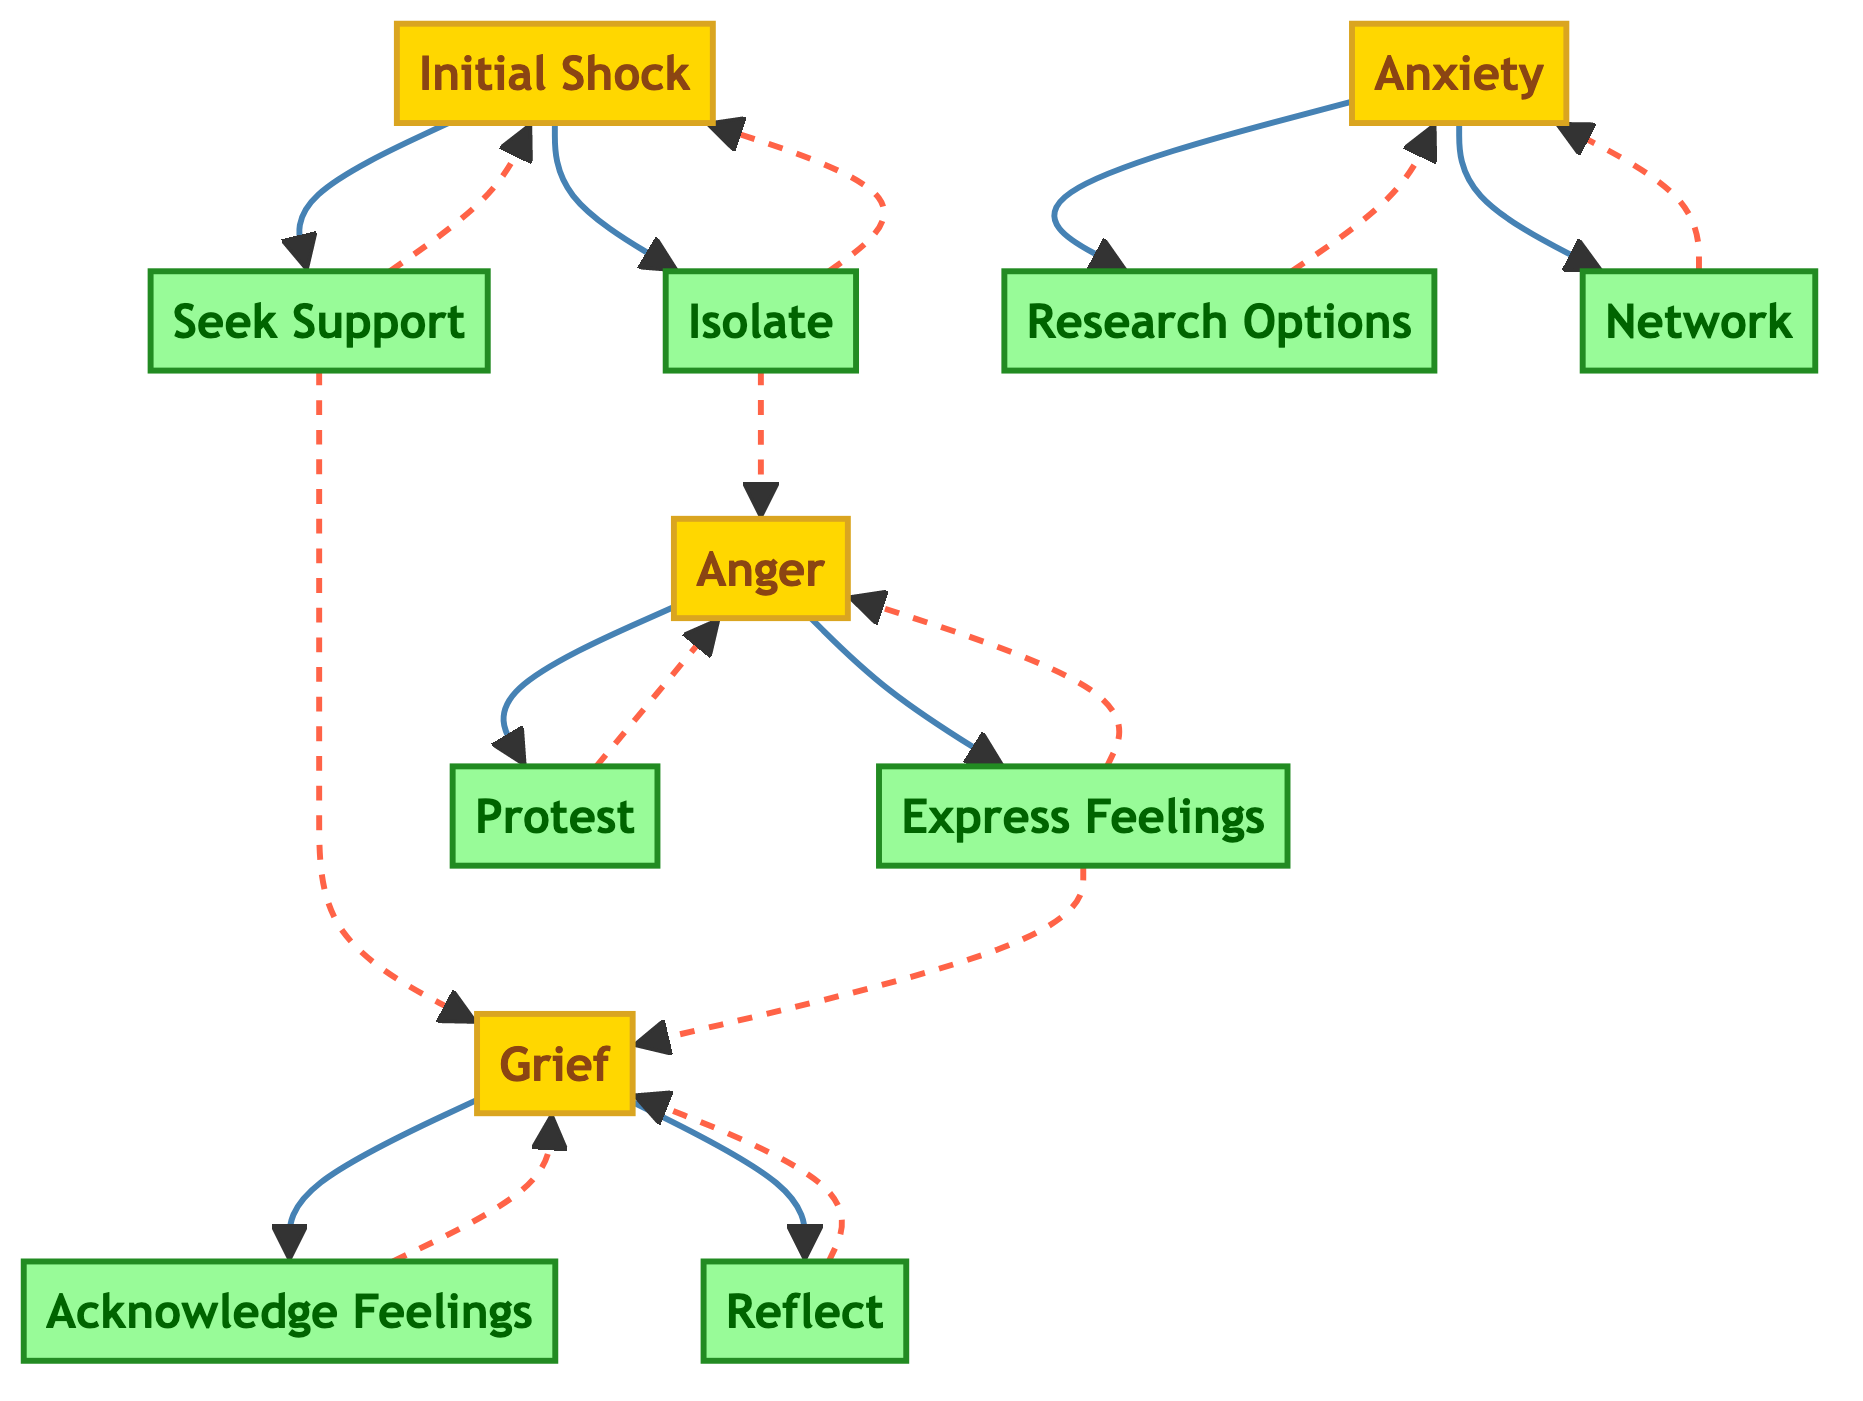What are the emotional responses listed in the diagram? The diagram lists four emotional responses: Initial Shock, Anger, Grief, and Anxiety.
Answer: Initial Shock, Anger, Grief, Anxiety How many coping mechanisms are identified in the diagram? The diagram shows eight coping mechanisms: Seek Support, Isolate, Express Feelings, Research Options, Acknowledge Feelings, Network, Reflect, and Protest. To find this, count each mechanism mentioned under the coping mechanisms section.
Answer: 8 Which emotion leads to the coping mechanism 'Express Feelings'? 'Express Feelings' is connected to two emotions: Anger and Grief. You can identify this by following the arrows from each emotion node that point to this coping mechanism node.
Answer: Anger, Grief What is the next step after 'Initial Shock'? After 'Initial Shock', the diagram indicates two potential next steps: Seek Support and Isolate. By checking the connections leading out of the 'Initial Shock' node, these two coping options are revealed.
Answer: Seek Support, Isolate Which coping mechanism is related to the emotion 'Anxiety'? The coping mechanisms connected to 'Anxiety' are Research Options and Network. This can be determined by examining the arrows leading from the 'Anxiety' emotion node to the corresponding coping nodes.
Answer: Research Options, Network What emotion is linked with the coping mechanism 'Acknowledge Feelings'? The diagram indicates that 'Acknowledge Feelings' is associated solely with the emotion 'Grief'. This relationship is evident from the directed connection between the nodes.
Answer: Grief Which emotional response has the most coping mechanisms associated? The emotional response 'Anger' is associated with two coping mechanisms, Express Feelings and Protest. In contrast, some emotions have fewer connections, making this the one with the most linked mechanisms.
Answer: Anger How many edges connect the emotion 'Grief' to coping mechanisms? The emotion 'Grief' has three edges connecting it to coping mechanisms: Acknowledge Feelings, Reflect, and Express Feelings. Counting the arrows from the 'Grief' node, you can see these connections clearly.
Answer: 3 